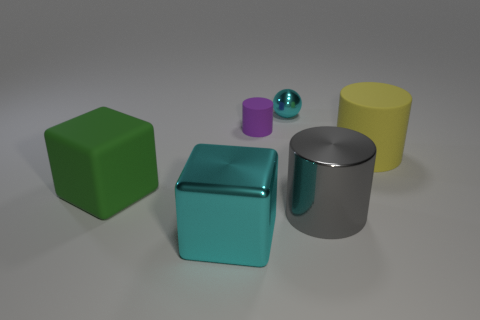Which objects in the image have a reflective surface? The cylindrical silver object and the small spherical object both have highly reflective surfaces that mirror their surroundings. 